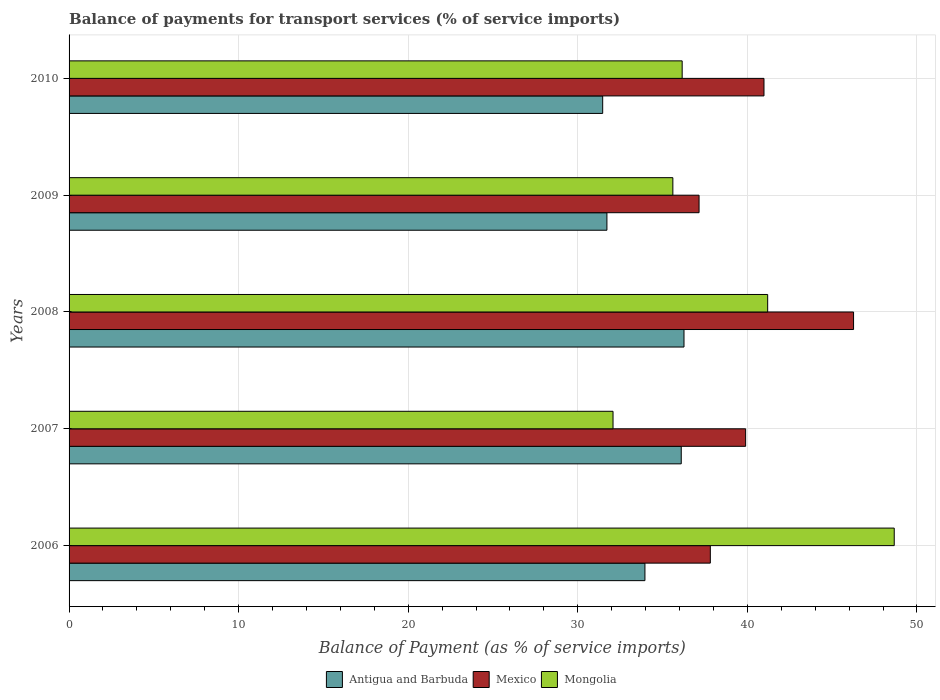How many different coloured bars are there?
Provide a succinct answer. 3. How many groups of bars are there?
Offer a very short reply. 5. Are the number of bars on each tick of the Y-axis equal?
Keep it short and to the point. Yes. What is the label of the 2nd group of bars from the top?
Provide a short and direct response. 2009. What is the balance of payments for transport services in Mexico in 2009?
Offer a terse response. 37.15. Across all years, what is the maximum balance of payments for transport services in Mongolia?
Provide a short and direct response. 48.66. Across all years, what is the minimum balance of payments for transport services in Mongolia?
Provide a succinct answer. 32.08. In which year was the balance of payments for transport services in Antigua and Barbuda maximum?
Provide a short and direct response. 2008. What is the total balance of payments for transport services in Mongolia in the graph?
Provide a short and direct response. 193.69. What is the difference between the balance of payments for transport services in Antigua and Barbuda in 2006 and that in 2007?
Your response must be concise. -2.14. What is the difference between the balance of payments for transport services in Antigua and Barbuda in 2006 and the balance of payments for transport services in Mongolia in 2009?
Offer a very short reply. -1.65. What is the average balance of payments for transport services in Mongolia per year?
Your answer should be compact. 38.74. In the year 2008, what is the difference between the balance of payments for transport services in Mongolia and balance of payments for transport services in Mexico?
Provide a short and direct response. -5.07. What is the ratio of the balance of payments for transport services in Mexico in 2007 to that in 2010?
Your response must be concise. 0.97. Is the difference between the balance of payments for transport services in Mongolia in 2007 and 2008 greater than the difference between the balance of payments for transport services in Mexico in 2007 and 2008?
Offer a terse response. No. What is the difference between the highest and the second highest balance of payments for transport services in Mongolia?
Offer a terse response. 7.46. What is the difference between the highest and the lowest balance of payments for transport services in Mongolia?
Give a very brief answer. 16.58. In how many years, is the balance of payments for transport services in Mongolia greater than the average balance of payments for transport services in Mongolia taken over all years?
Your answer should be compact. 2. Is the sum of the balance of payments for transport services in Mongolia in 2006 and 2010 greater than the maximum balance of payments for transport services in Mexico across all years?
Your answer should be compact. Yes. What does the 1st bar from the top in 2010 represents?
Ensure brevity in your answer.  Mongolia. What does the 1st bar from the bottom in 2008 represents?
Give a very brief answer. Antigua and Barbuda. Is it the case that in every year, the sum of the balance of payments for transport services in Antigua and Barbuda and balance of payments for transport services in Mongolia is greater than the balance of payments for transport services in Mexico?
Your response must be concise. Yes. How many bars are there?
Your answer should be very brief. 15. What is the difference between two consecutive major ticks on the X-axis?
Provide a short and direct response. 10. Are the values on the major ticks of X-axis written in scientific E-notation?
Give a very brief answer. No. Does the graph contain grids?
Make the answer very short. Yes. Where does the legend appear in the graph?
Give a very brief answer. Bottom center. How many legend labels are there?
Make the answer very short. 3. How are the legend labels stacked?
Provide a short and direct response. Horizontal. What is the title of the graph?
Offer a very short reply. Balance of payments for transport services (% of service imports). What is the label or title of the X-axis?
Your answer should be very brief. Balance of Payment (as % of service imports). What is the label or title of the Y-axis?
Give a very brief answer. Years. What is the Balance of Payment (as % of service imports) in Antigua and Barbuda in 2006?
Make the answer very short. 33.96. What is the Balance of Payment (as % of service imports) in Mexico in 2006?
Ensure brevity in your answer.  37.81. What is the Balance of Payment (as % of service imports) of Mongolia in 2006?
Ensure brevity in your answer.  48.66. What is the Balance of Payment (as % of service imports) in Antigua and Barbuda in 2007?
Offer a very short reply. 36.1. What is the Balance of Payment (as % of service imports) of Mexico in 2007?
Offer a very short reply. 39.9. What is the Balance of Payment (as % of service imports) in Mongolia in 2007?
Your answer should be compact. 32.08. What is the Balance of Payment (as % of service imports) of Antigua and Barbuda in 2008?
Your answer should be very brief. 36.26. What is the Balance of Payment (as % of service imports) in Mexico in 2008?
Ensure brevity in your answer.  46.26. What is the Balance of Payment (as % of service imports) of Mongolia in 2008?
Your answer should be compact. 41.19. What is the Balance of Payment (as % of service imports) in Antigua and Barbuda in 2009?
Keep it short and to the point. 31.72. What is the Balance of Payment (as % of service imports) of Mexico in 2009?
Give a very brief answer. 37.15. What is the Balance of Payment (as % of service imports) of Mongolia in 2009?
Ensure brevity in your answer.  35.6. What is the Balance of Payment (as % of service imports) in Antigua and Barbuda in 2010?
Make the answer very short. 31.47. What is the Balance of Payment (as % of service imports) of Mexico in 2010?
Make the answer very short. 40.98. What is the Balance of Payment (as % of service imports) in Mongolia in 2010?
Give a very brief answer. 36.15. Across all years, what is the maximum Balance of Payment (as % of service imports) in Antigua and Barbuda?
Offer a terse response. 36.26. Across all years, what is the maximum Balance of Payment (as % of service imports) of Mexico?
Provide a succinct answer. 46.26. Across all years, what is the maximum Balance of Payment (as % of service imports) of Mongolia?
Provide a short and direct response. 48.66. Across all years, what is the minimum Balance of Payment (as % of service imports) in Antigua and Barbuda?
Ensure brevity in your answer.  31.47. Across all years, what is the minimum Balance of Payment (as % of service imports) in Mexico?
Give a very brief answer. 37.15. Across all years, what is the minimum Balance of Payment (as % of service imports) of Mongolia?
Keep it short and to the point. 32.08. What is the total Balance of Payment (as % of service imports) in Antigua and Barbuda in the graph?
Your answer should be compact. 169.5. What is the total Balance of Payment (as % of service imports) in Mexico in the graph?
Your response must be concise. 202.1. What is the total Balance of Payment (as % of service imports) in Mongolia in the graph?
Provide a succinct answer. 193.69. What is the difference between the Balance of Payment (as % of service imports) in Antigua and Barbuda in 2006 and that in 2007?
Your answer should be compact. -2.14. What is the difference between the Balance of Payment (as % of service imports) of Mexico in 2006 and that in 2007?
Provide a short and direct response. -2.08. What is the difference between the Balance of Payment (as % of service imports) of Mongolia in 2006 and that in 2007?
Provide a succinct answer. 16.58. What is the difference between the Balance of Payment (as % of service imports) of Antigua and Barbuda in 2006 and that in 2008?
Your answer should be compact. -2.3. What is the difference between the Balance of Payment (as % of service imports) of Mexico in 2006 and that in 2008?
Keep it short and to the point. -8.45. What is the difference between the Balance of Payment (as % of service imports) in Mongolia in 2006 and that in 2008?
Provide a succinct answer. 7.46. What is the difference between the Balance of Payment (as % of service imports) in Antigua and Barbuda in 2006 and that in 2009?
Your response must be concise. 2.24. What is the difference between the Balance of Payment (as % of service imports) in Mexico in 2006 and that in 2009?
Make the answer very short. 0.66. What is the difference between the Balance of Payment (as % of service imports) in Mongolia in 2006 and that in 2009?
Offer a very short reply. 13.05. What is the difference between the Balance of Payment (as % of service imports) of Antigua and Barbuda in 2006 and that in 2010?
Your answer should be very brief. 2.49. What is the difference between the Balance of Payment (as % of service imports) of Mexico in 2006 and that in 2010?
Your answer should be very brief. -3.16. What is the difference between the Balance of Payment (as % of service imports) in Mongolia in 2006 and that in 2010?
Give a very brief answer. 12.5. What is the difference between the Balance of Payment (as % of service imports) of Antigua and Barbuda in 2007 and that in 2008?
Offer a very short reply. -0.16. What is the difference between the Balance of Payment (as % of service imports) in Mexico in 2007 and that in 2008?
Keep it short and to the point. -6.36. What is the difference between the Balance of Payment (as % of service imports) of Mongolia in 2007 and that in 2008?
Give a very brief answer. -9.12. What is the difference between the Balance of Payment (as % of service imports) of Antigua and Barbuda in 2007 and that in 2009?
Your response must be concise. 4.38. What is the difference between the Balance of Payment (as % of service imports) of Mexico in 2007 and that in 2009?
Offer a very short reply. 2.75. What is the difference between the Balance of Payment (as % of service imports) in Mongolia in 2007 and that in 2009?
Your answer should be compact. -3.53. What is the difference between the Balance of Payment (as % of service imports) in Antigua and Barbuda in 2007 and that in 2010?
Keep it short and to the point. 4.63. What is the difference between the Balance of Payment (as % of service imports) of Mexico in 2007 and that in 2010?
Your answer should be compact. -1.08. What is the difference between the Balance of Payment (as % of service imports) of Mongolia in 2007 and that in 2010?
Your answer should be very brief. -4.08. What is the difference between the Balance of Payment (as % of service imports) in Antigua and Barbuda in 2008 and that in 2009?
Keep it short and to the point. 4.55. What is the difference between the Balance of Payment (as % of service imports) of Mexico in 2008 and that in 2009?
Provide a short and direct response. 9.11. What is the difference between the Balance of Payment (as % of service imports) of Mongolia in 2008 and that in 2009?
Offer a terse response. 5.59. What is the difference between the Balance of Payment (as % of service imports) in Antigua and Barbuda in 2008 and that in 2010?
Provide a short and direct response. 4.8. What is the difference between the Balance of Payment (as % of service imports) in Mexico in 2008 and that in 2010?
Offer a very short reply. 5.28. What is the difference between the Balance of Payment (as % of service imports) in Mongolia in 2008 and that in 2010?
Your answer should be very brief. 5.04. What is the difference between the Balance of Payment (as % of service imports) of Mexico in 2009 and that in 2010?
Ensure brevity in your answer.  -3.83. What is the difference between the Balance of Payment (as % of service imports) of Mongolia in 2009 and that in 2010?
Provide a short and direct response. -0.55. What is the difference between the Balance of Payment (as % of service imports) in Antigua and Barbuda in 2006 and the Balance of Payment (as % of service imports) in Mexico in 2007?
Offer a terse response. -5.94. What is the difference between the Balance of Payment (as % of service imports) of Antigua and Barbuda in 2006 and the Balance of Payment (as % of service imports) of Mongolia in 2007?
Offer a very short reply. 1.88. What is the difference between the Balance of Payment (as % of service imports) of Mexico in 2006 and the Balance of Payment (as % of service imports) of Mongolia in 2007?
Give a very brief answer. 5.74. What is the difference between the Balance of Payment (as % of service imports) in Antigua and Barbuda in 2006 and the Balance of Payment (as % of service imports) in Mexico in 2008?
Provide a short and direct response. -12.3. What is the difference between the Balance of Payment (as % of service imports) in Antigua and Barbuda in 2006 and the Balance of Payment (as % of service imports) in Mongolia in 2008?
Ensure brevity in your answer.  -7.24. What is the difference between the Balance of Payment (as % of service imports) of Mexico in 2006 and the Balance of Payment (as % of service imports) of Mongolia in 2008?
Make the answer very short. -3.38. What is the difference between the Balance of Payment (as % of service imports) in Antigua and Barbuda in 2006 and the Balance of Payment (as % of service imports) in Mexico in 2009?
Make the answer very short. -3.19. What is the difference between the Balance of Payment (as % of service imports) of Antigua and Barbuda in 2006 and the Balance of Payment (as % of service imports) of Mongolia in 2009?
Make the answer very short. -1.65. What is the difference between the Balance of Payment (as % of service imports) of Mexico in 2006 and the Balance of Payment (as % of service imports) of Mongolia in 2009?
Your response must be concise. 2.21. What is the difference between the Balance of Payment (as % of service imports) of Antigua and Barbuda in 2006 and the Balance of Payment (as % of service imports) of Mexico in 2010?
Offer a very short reply. -7.02. What is the difference between the Balance of Payment (as % of service imports) in Antigua and Barbuda in 2006 and the Balance of Payment (as % of service imports) in Mongolia in 2010?
Your answer should be compact. -2.2. What is the difference between the Balance of Payment (as % of service imports) in Mexico in 2006 and the Balance of Payment (as % of service imports) in Mongolia in 2010?
Make the answer very short. 1.66. What is the difference between the Balance of Payment (as % of service imports) of Antigua and Barbuda in 2007 and the Balance of Payment (as % of service imports) of Mexico in 2008?
Offer a terse response. -10.16. What is the difference between the Balance of Payment (as % of service imports) of Antigua and Barbuda in 2007 and the Balance of Payment (as % of service imports) of Mongolia in 2008?
Make the answer very short. -5.1. What is the difference between the Balance of Payment (as % of service imports) of Mexico in 2007 and the Balance of Payment (as % of service imports) of Mongolia in 2008?
Keep it short and to the point. -1.3. What is the difference between the Balance of Payment (as % of service imports) in Antigua and Barbuda in 2007 and the Balance of Payment (as % of service imports) in Mexico in 2009?
Offer a very short reply. -1.05. What is the difference between the Balance of Payment (as % of service imports) in Antigua and Barbuda in 2007 and the Balance of Payment (as % of service imports) in Mongolia in 2009?
Your response must be concise. 0.49. What is the difference between the Balance of Payment (as % of service imports) of Mexico in 2007 and the Balance of Payment (as % of service imports) of Mongolia in 2009?
Your answer should be very brief. 4.29. What is the difference between the Balance of Payment (as % of service imports) in Antigua and Barbuda in 2007 and the Balance of Payment (as % of service imports) in Mexico in 2010?
Provide a succinct answer. -4.88. What is the difference between the Balance of Payment (as % of service imports) of Antigua and Barbuda in 2007 and the Balance of Payment (as % of service imports) of Mongolia in 2010?
Your response must be concise. -0.05. What is the difference between the Balance of Payment (as % of service imports) of Mexico in 2007 and the Balance of Payment (as % of service imports) of Mongolia in 2010?
Your response must be concise. 3.74. What is the difference between the Balance of Payment (as % of service imports) of Antigua and Barbuda in 2008 and the Balance of Payment (as % of service imports) of Mexico in 2009?
Offer a very short reply. -0.89. What is the difference between the Balance of Payment (as % of service imports) in Antigua and Barbuda in 2008 and the Balance of Payment (as % of service imports) in Mongolia in 2009?
Make the answer very short. 0.66. What is the difference between the Balance of Payment (as % of service imports) in Mexico in 2008 and the Balance of Payment (as % of service imports) in Mongolia in 2009?
Keep it short and to the point. 10.66. What is the difference between the Balance of Payment (as % of service imports) in Antigua and Barbuda in 2008 and the Balance of Payment (as % of service imports) in Mexico in 2010?
Your answer should be compact. -4.72. What is the difference between the Balance of Payment (as % of service imports) in Antigua and Barbuda in 2008 and the Balance of Payment (as % of service imports) in Mongolia in 2010?
Make the answer very short. 0.11. What is the difference between the Balance of Payment (as % of service imports) of Mexico in 2008 and the Balance of Payment (as % of service imports) of Mongolia in 2010?
Ensure brevity in your answer.  10.11. What is the difference between the Balance of Payment (as % of service imports) in Antigua and Barbuda in 2009 and the Balance of Payment (as % of service imports) in Mexico in 2010?
Your answer should be very brief. -9.26. What is the difference between the Balance of Payment (as % of service imports) in Antigua and Barbuda in 2009 and the Balance of Payment (as % of service imports) in Mongolia in 2010?
Offer a terse response. -4.44. What is the difference between the Balance of Payment (as % of service imports) of Mexico in 2009 and the Balance of Payment (as % of service imports) of Mongolia in 2010?
Offer a very short reply. 1. What is the average Balance of Payment (as % of service imports) of Antigua and Barbuda per year?
Offer a very short reply. 33.9. What is the average Balance of Payment (as % of service imports) of Mexico per year?
Provide a succinct answer. 40.42. What is the average Balance of Payment (as % of service imports) of Mongolia per year?
Your answer should be compact. 38.74. In the year 2006, what is the difference between the Balance of Payment (as % of service imports) of Antigua and Barbuda and Balance of Payment (as % of service imports) of Mexico?
Make the answer very short. -3.86. In the year 2006, what is the difference between the Balance of Payment (as % of service imports) of Antigua and Barbuda and Balance of Payment (as % of service imports) of Mongolia?
Your response must be concise. -14.7. In the year 2006, what is the difference between the Balance of Payment (as % of service imports) of Mexico and Balance of Payment (as % of service imports) of Mongolia?
Offer a terse response. -10.84. In the year 2007, what is the difference between the Balance of Payment (as % of service imports) of Antigua and Barbuda and Balance of Payment (as % of service imports) of Mexico?
Offer a very short reply. -3.8. In the year 2007, what is the difference between the Balance of Payment (as % of service imports) in Antigua and Barbuda and Balance of Payment (as % of service imports) in Mongolia?
Your response must be concise. 4.02. In the year 2007, what is the difference between the Balance of Payment (as % of service imports) in Mexico and Balance of Payment (as % of service imports) in Mongolia?
Make the answer very short. 7.82. In the year 2008, what is the difference between the Balance of Payment (as % of service imports) of Antigua and Barbuda and Balance of Payment (as % of service imports) of Mexico?
Provide a succinct answer. -10. In the year 2008, what is the difference between the Balance of Payment (as % of service imports) in Antigua and Barbuda and Balance of Payment (as % of service imports) in Mongolia?
Your answer should be compact. -4.93. In the year 2008, what is the difference between the Balance of Payment (as % of service imports) of Mexico and Balance of Payment (as % of service imports) of Mongolia?
Provide a succinct answer. 5.07. In the year 2009, what is the difference between the Balance of Payment (as % of service imports) of Antigua and Barbuda and Balance of Payment (as % of service imports) of Mexico?
Make the answer very short. -5.43. In the year 2009, what is the difference between the Balance of Payment (as % of service imports) of Antigua and Barbuda and Balance of Payment (as % of service imports) of Mongolia?
Provide a short and direct response. -3.89. In the year 2009, what is the difference between the Balance of Payment (as % of service imports) in Mexico and Balance of Payment (as % of service imports) in Mongolia?
Give a very brief answer. 1.54. In the year 2010, what is the difference between the Balance of Payment (as % of service imports) in Antigua and Barbuda and Balance of Payment (as % of service imports) in Mexico?
Keep it short and to the point. -9.51. In the year 2010, what is the difference between the Balance of Payment (as % of service imports) in Antigua and Barbuda and Balance of Payment (as % of service imports) in Mongolia?
Ensure brevity in your answer.  -4.69. In the year 2010, what is the difference between the Balance of Payment (as % of service imports) in Mexico and Balance of Payment (as % of service imports) in Mongolia?
Give a very brief answer. 4.82. What is the ratio of the Balance of Payment (as % of service imports) in Antigua and Barbuda in 2006 to that in 2007?
Make the answer very short. 0.94. What is the ratio of the Balance of Payment (as % of service imports) of Mexico in 2006 to that in 2007?
Provide a succinct answer. 0.95. What is the ratio of the Balance of Payment (as % of service imports) in Mongolia in 2006 to that in 2007?
Offer a very short reply. 1.52. What is the ratio of the Balance of Payment (as % of service imports) of Antigua and Barbuda in 2006 to that in 2008?
Keep it short and to the point. 0.94. What is the ratio of the Balance of Payment (as % of service imports) in Mexico in 2006 to that in 2008?
Make the answer very short. 0.82. What is the ratio of the Balance of Payment (as % of service imports) of Mongolia in 2006 to that in 2008?
Keep it short and to the point. 1.18. What is the ratio of the Balance of Payment (as % of service imports) in Antigua and Barbuda in 2006 to that in 2009?
Your answer should be compact. 1.07. What is the ratio of the Balance of Payment (as % of service imports) of Mexico in 2006 to that in 2009?
Provide a succinct answer. 1.02. What is the ratio of the Balance of Payment (as % of service imports) in Mongolia in 2006 to that in 2009?
Your answer should be compact. 1.37. What is the ratio of the Balance of Payment (as % of service imports) in Antigua and Barbuda in 2006 to that in 2010?
Make the answer very short. 1.08. What is the ratio of the Balance of Payment (as % of service imports) in Mexico in 2006 to that in 2010?
Give a very brief answer. 0.92. What is the ratio of the Balance of Payment (as % of service imports) in Mongolia in 2006 to that in 2010?
Offer a terse response. 1.35. What is the ratio of the Balance of Payment (as % of service imports) in Mexico in 2007 to that in 2008?
Offer a terse response. 0.86. What is the ratio of the Balance of Payment (as % of service imports) of Mongolia in 2007 to that in 2008?
Provide a short and direct response. 0.78. What is the ratio of the Balance of Payment (as % of service imports) in Antigua and Barbuda in 2007 to that in 2009?
Offer a terse response. 1.14. What is the ratio of the Balance of Payment (as % of service imports) in Mexico in 2007 to that in 2009?
Your answer should be compact. 1.07. What is the ratio of the Balance of Payment (as % of service imports) in Mongolia in 2007 to that in 2009?
Ensure brevity in your answer.  0.9. What is the ratio of the Balance of Payment (as % of service imports) of Antigua and Barbuda in 2007 to that in 2010?
Keep it short and to the point. 1.15. What is the ratio of the Balance of Payment (as % of service imports) of Mexico in 2007 to that in 2010?
Provide a succinct answer. 0.97. What is the ratio of the Balance of Payment (as % of service imports) of Mongolia in 2007 to that in 2010?
Offer a terse response. 0.89. What is the ratio of the Balance of Payment (as % of service imports) of Antigua and Barbuda in 2008 to that in 2009?
Ensure brevity in your answer.  1.14. What is the ratio of the Balance of Payment (as % of service imports) of Mexico in 2008 to that in 2009?
Make the answer very short. 1.25. What is the ratio of the Balance of Payment (as % of service imports) of Mongolia in 2008 to that in 2009?
Keep it short and to the point. 1.16. What is the ratio of the Balance of Payment (as % of service imports) of Antigua and Barbuda in 2008 to that in 2010?
Give a very brief answer. 1.15. What is the ratio of the Balance of Payment (as % of service imports) in Mexico in 2008 to that in 2010?
Make the answer very short. 1.13. What is the ratio of the Balance of Payment (as % of service imports) in Mongolia in 2008 to that in 2010?
Offer a very short reply. 1.14. What is the ratio of the Balance of Payment (as % of service imports) in Antigua and Barbuda in 2009 to that in 2010?
Offer a very short reply. 1.01. What is the ratio of the Balance of Payment (as % of service imports) of Mexico in 2009 to that in 2010?
Give a very brief answer. 0.91. What is the difference between the highest and the second highest Balance of Payment (as % of service imports) in Antigua and Barbuda?
Make the answer very short. 0.16. What is the difference between the highest and the second highest Balance of Payment (as % of service imports) of Mexico?
Keep it short and to the point. 5.28. What is the difference between the highest and the second highest Balance of Payment (as % of service imports) of Mongolia?
Ensure brevity in your answer.  7.46. What is the difference between the highest and the lowest Balance of Payment (as % of service imports) in Antigua and Barbuda?
Make the answer very short. 4.8. What is the difference between the highest and the lowest Balance of Payment (as % of service imports) of Mexico?
Provide a short and direct response. 9.11. What is the difference between the highest and the lowest Balance of Payment (as % of service imports) in Mongolia?
Provide a succinct answer. 16.58. 